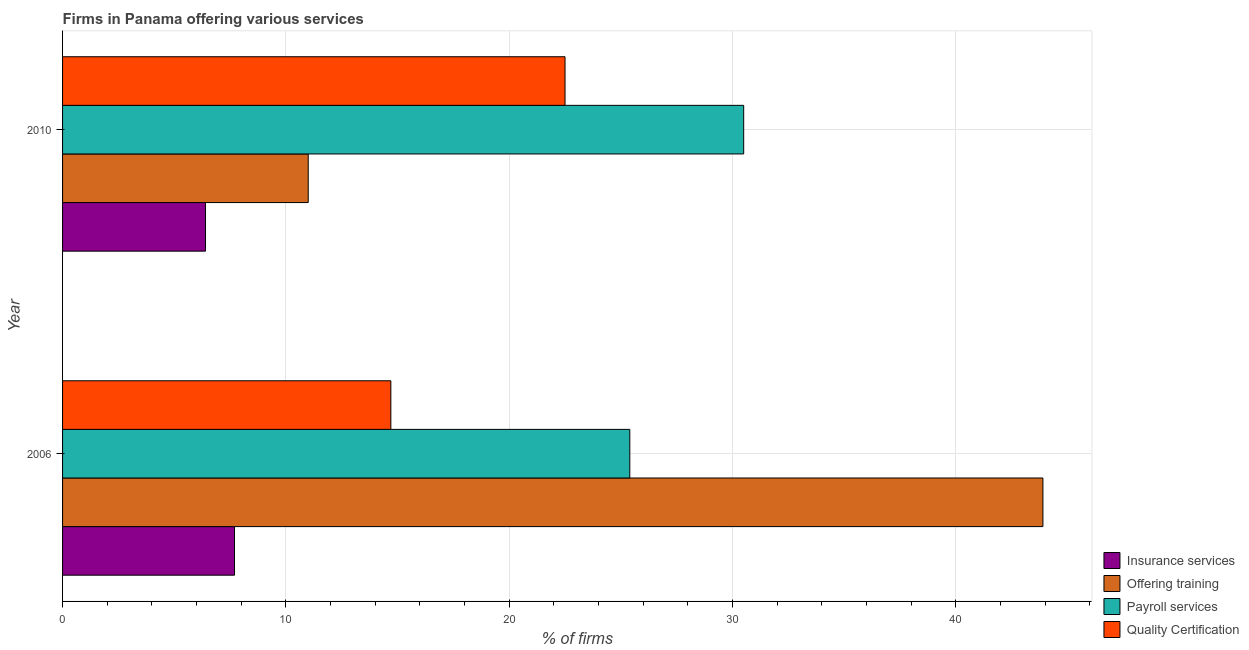Are the number of bars on each tick of the Y-axis equal?
Offer a very short reply. Yes. How many bars are there on the 1st tick from the bottom?
Provide a short and direct response. 4. What is the label of the 2nd group of bars from the top?
Your answer should be compact. 2006. In how many cases, is the number of bars for a given year not equal to the number of legend labels?
Your answer should be compact. 0. What is the percentage of firms offering payroll services in 2010?
Give a very brief answer. 30.5. Across all years, what is the maximum percentage of firms offering training?
Give a very brief answer. 43.9. Across all years, what is the minimum percentage of firms offering insurance services?
Provide a succinct answer. 6.4. In which year was the percentage of firms offering quality certification maximum?
Make the answer very short. 2010. What is the total percentage of firms offering insurance services in the graph?
Keep it short and to the point. 14.1. What is the difference between the percentage of firms offering quality certification in 2006 and that in 2010?
Give a very brief answer. -7.8. What is the difference between the percentage of firms offering payroll services in 2010 and the percentage of firms offering training in 2006?
Your answer should be compact. -13.4. What is the average percentage of firms offering payroll services per year?
Ensure brevity in your answer.  27.95. What is the ratio of the percentage of firms offering quality certification in 2006 to that in 2010?
Make the answer very short. 0.65. Is the percentage of firms offering training in 2006 less than that in 2010?
Your response must be concise. No. Is the difference between the percentage of firms offering training in 2006 and 2010 greater than the difference between the percentage of firms offering insurance services in 2006 and 2010?
Provide a succinct answer. Yes. What does the 1st bar from the top in 2010 represents?
Your answer should be very brief. Quality Certification. What does the 3rd bar from the bottom in 2006 represents?
Provide a short and direct response. Payroll services. Is it the case that in every year, the sum of the percentage of firms offering insurance services and percentage of firms offering training is greater than the percentage of firms offering payroll services?
Offer a terse response. No. Are the values on the major ticks of X-axis written in scientific E-notation?
Ensure brevity in your answer.  No. Does the graph contain any zero values?
Provide a short and direct response. No. Does the graph contain grids?
Your answer should be compact. Yes. Where does the legend appear in the graph?
Your response must be concise. Bottom right. How are the legend labels stacked?
Provide a short and direct response. Vertical. What is the title of the graph?
Ensure brevity in your answer.  Firms in Panama offering various services . Does "Tertiary schools" appear as one of the legend labels in the graph?
Your response must be concise. No. What is the label or title of the X-axis?
Give a very brief answer. % of firms. What is the label or title of the Y-axis?
Your answer should be very brief. Year. What is the % of firms in Offering training in 2006?
Your answer should be very brief. 43.9. What is the % of firms of Payroll services in 2006?
Your answer should be very brief. 25.4. What is the % of firms of Quality Certification in 2006?
Offer a very short reply. 14.7. What is the % of firms of Payroll services in 2010?
Give a very brief answer. 30.5. Across all years, what is the maximum % of firms in Offering training?
Provide a short and direct response. 43.9. Across all years, what is the maximum % of firms in Payroll services?
Offer a terse response. 30.5. Across all years, what is the maximum % of firms in Quality Certification?
Offer a very short reply. 22.5. Across all years, what is the minimum % of firms in Insurance services?
Give a very brief answer. 6.4. Across all years, what is the minimum % of firms in Payroll services?
Your answer should be very brief. 25.4. What is the total % of firms of Offering training in the graph?
Offer a very short reply. 54.9. What is the total % of firms in Payroll services in the graph?
Your answer should be compact. 55.9. What is the total % of firms in Quality Certification in the graph?
Make the answer very short. 37.2. What is the difference between the % of firms in Offering training in 2006 and that in 2010?
Offer a very short reply. 32.9. What is the difference between the % of firms in Payroll services in 2006 and that in 2010?
Provide a short and direct response. -5.1. What is the difference between the % of firms of Insurance services in 2006 and the % of firms of Offering training in 2010?
Provide a short and direct response. -3.3. What is the difference between the % of firms of Insurance services in 2006 and the % of firms of Payroll services in 2010?
Ensure brevity in your answer.  -22.8. What is the difference between the % of firms in Insurance services in 2006 and the % of firms in Quality Certification in 2010?
Provide a succinct answer. -14.8. What is the difference between the % of firms of Offering training in 2006 and the % of firms of Payroll services in 2010?
Make the answer very short. 13.4. What is the difference between the % of firms of Offering training in 2006 and the % of firms of Quality Certification in 2010?
Offer a very short reply. 21.4. What is the difference between the % of firms of Payroll services in 2006 and the % of firms of Quality Certification in 2010?
Keep it short and to the point. 2.9. What is the average % of firms of Insurance services per year?
Your answer should be very brief. 7.05. What is the average % of firms in Offering training per year?
Your response must be concise. 27.45. What is the average % of firms of Payroll services per year?
Your response must be concise. 27.95. What is the average % of firms in Quality Certification per year?
Your response must be concise. 18.6. In the year 2006, what is the difference between the % of firms of Insurance services and % of firms of Offering training?
Provide a short and direct response. -36.2. In the year 2006, what is the difference between the % of firms of Insurance services and % of firms of Payroll services?
Provide a short and direct response. -17.7. In the year 2006, what is the difference between the % of firms in Offering training and % of firms in Quality Certification?
Offer a terse response. 29.2. In the year 2010, what is the difference between the % of firms in Insurance services and % of firms in Offering training?
Make the answer very short. -4.6. In the year 2010, what is the difference between the % of firms in Insurance services and % of firms in Payroll services?
Provide a succinct answer. -24.1. In the year 2010, what is the difference between the % of firms of Insurance services and % of firms of Quality Certification?
Provide a short and direct response. -16.1. In the year 2010, what is the difference between the % of firms in Offering training and % of firms in Payroll services?
Give a very brief answer. -19.5. In the year 2010, what is the difference between the % of firms in Offering training and % of firms in Quality Certification?
Offer a terse response. -11.5. What is the ratio of the % of firms of Insurance services in 2006 to that in 2010?
Provide a short and direct response. 1.2. What is the ratio of the % of firms in Offering training in 2006 to that in 2010?
Ensure brevity in your answer.  3.99. What is the ratio of the % of firms in Payroll services in 2006 to that in 2010?
Offer a terse response. 0.83. What is the ratio of the % of firms in Quality Certification in 2006 to that in 2010?
Your answer should be very brief. 0.65. What is the difference between the highest and the second highest % of firms in Offering training?
Offer a very short reply. 32.9. What is the difference between the highest and the second highest % of firms in Payroll services?
Make the answer very short. 5.1. What is the difference between the highest and the lowest % of firms in Offering training?
Make the answer very short. 32.9. What is the difference between the highest and the lowest % of firms in Payroll services?
Make the answer very short. 5.1. What is the difference between the highest and the lowest % of firms of Quality Certification?
Your answer should be compact. 7.8. 